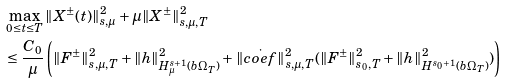<formula> <loc_0><loc_0><loc_500><loc_500>& \max _ { 0 \leq t \leq T } \| X ^ { \pm } ( t ) \| _ { s , \mu } ^ { 2 } + \mu \| X ^ { \pm } \| _ { s , \mu , T } ^ { 2 } \\ & \leq \frac { C _ { 0 } } { \mu } \left ( \| { F } ^ { \pm } \| _ { s , \mu , T } ^ { 2 } + \| { h } \| _ { H ^ { s + 1 } _ { \mu } ( b \Omega _ { T } ) } ^ { 2 } + \| \dot { c o e f } \| _ { s , \mu , T } ^ { 2 } ( \| { F } ^ { \pm } \| _ { s _ { 0 } , T } ^ { 2 } + \| { h } \| _ { H ^ { s _ { 0 } + 1 } ( b \Omega _ { T } ) } ^ { 2 } ) \right )</formula> 